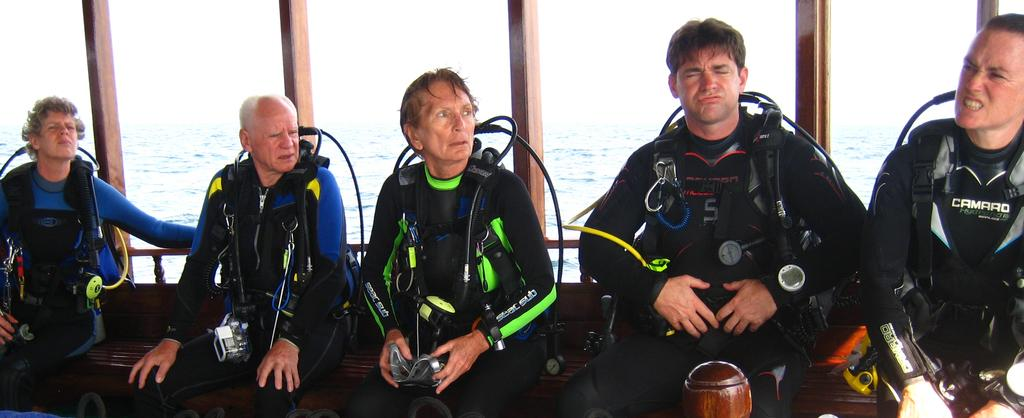What is happening in the foreground of the image? There is a group of people in the foreground of the image. What are the people doing in the image? The people are sitting. What type of clothing are the people wearing? The people are wearing drysuits. What else can be seen in the image besides the group of people? There are other objects in the image. What is visible in the background of the image? There is a water surface in the background of the image. What type of bucket can be seen hanging from the branch in the image? There is no bucket or branch present in the image. Is the family in the image related to the person asking the questions? The image does not show any family members, and the relationship between the people in the image and the person asking the questions cannot be determined from the image. 